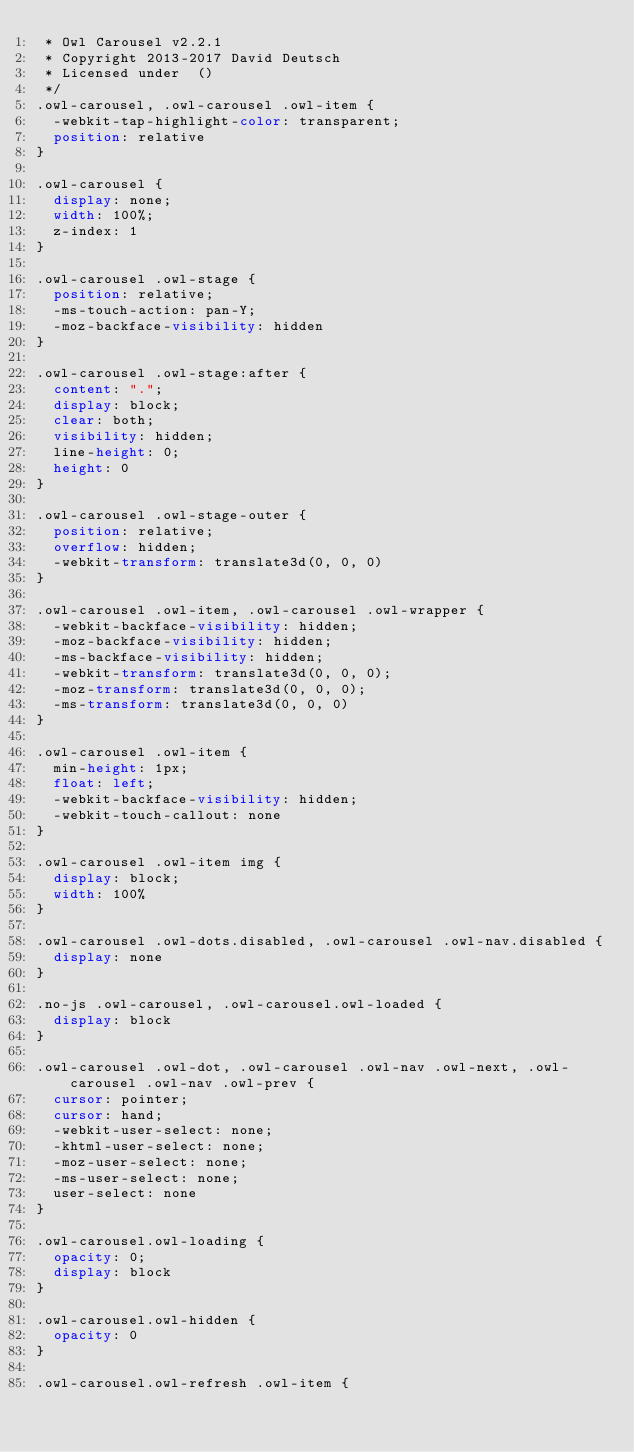<code> <loc_0><loc_0><loc_500><loc_500><_CSS_> * Owl Carousel v2.2.1
 * Copyright 2013-2017 David Deutsch
 * Licensed under  ()
 */
.owl-carousel, .owl-carousel .owl-item {
  -webkit-tap-highlight-color: transparent;
  position: relative
}

.owl-carousel {
  display: none;
  width: 100%;
  z-index: 1
}

.owl-carousel .owl-stage {
  position: relative;
  -ms-touch-action: pan-Y;
  -moz-backface-visibility: hidden
}

.owl-carousel .owl-stage:after {
  content: ".";
  display: block;
  clear: both;
  visibility: hidden;
  line-height: 0;
  height: 0
}

.owl-carousel .owl-stage-outer {
  position: relative;
  overflow: hidden;
  -webkit-transform: translate3d(0, 0, 0)
}

.owl-carousel .owl-item, .owl-carousel .owl-wrapper {
  -webkit-backface-visibility: hidden;
  -moz-backface-visibility: hidden;
  -ms-backface-visibility: hidden;
  -webkit-transform: translate3d(0, 0, 0);
  -moz-transform: translate3d(0, 0, 0);
  -ms-transform: translate3d(0, 0, 0)
}

.owl-carousel .owl-item {
  min-height: 1px;
  float: left;
  -webkit-backface-visibility: hidden;
  -webkit-touch-callout: none
}

.owl-carousel .owl-item img {
  display: block;
  width: 100%
}

.owl-carousel .owl-dots.disabled, .owl-carousel .owl-nav.disabled {
  display: none
}

.no-js .owl-carousel, .owl-carousel.owl-loaded {
  display: block
}

.owl-carousel .owl-dot, .owl-carousel .owl-nav .owl-next, .owl-carousel .owl-nav .owl-prev {
  cursor: pointer;
  cursor: hand;
  -webkit-user-select: none;
  -khtml-user-select: none;
  -moz-user-select: none;
  -ms-user-select: none;
  user-select: none
}

.owl-carousel.owl-loading {
  opacity: 0;
  display: block
}

.owl-carousel.owl-hidden {
  opacity: 0
}

.owl-carousel.owl-refresh .owl-item {</code> 